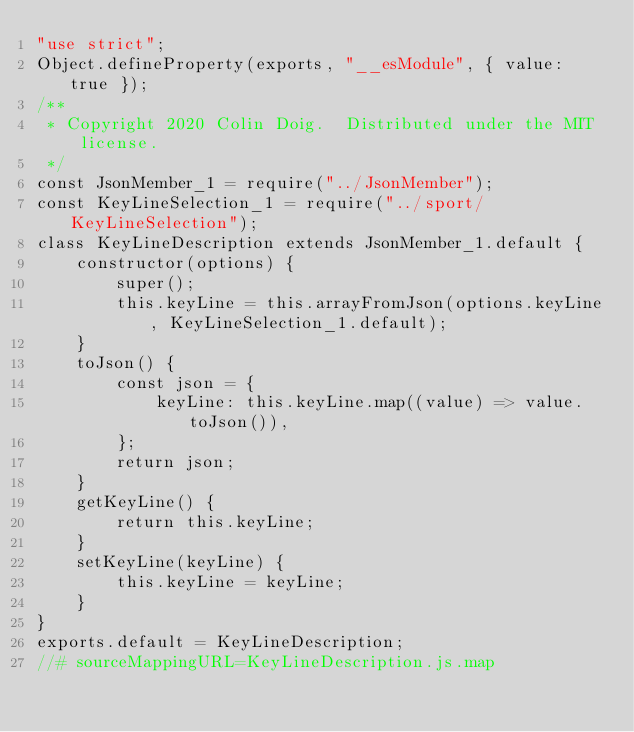<code> <loc_0><loc_0><loc_500><loc_500><_JavaScript_>"use strict";
Object.defineProperty(exports, "__esModule", { value: true });
/**
 * Copyright 2020 Colin Doig.  Distributed under the MIT license.
 */
const JsonMember_1 = require("../JsonMember");
const KeyLineSelection_1 = require("../sport/KeyLineSelection");
class KeyLineDescription extends JsonMember_1.default {
    constructor(options) {
        super();
        this.keyLine = this.arrayFromJson(options.keyLine, KeyLineSelection_1.default);
    }
    toJson() {
        const json = {
            keyLine: this.keyLine.map((value) => value.toJson()),
        };
        return json;
    }
    getKeyLine() {
        return this.keyLine;
    }
    setKeyLine(keyLine) {
        this.keyLine = keyLine;
    }
}
exports.default = KeyLineDescription;
//# sourceMappingURL=KeyLineDescription.js.map</code> 